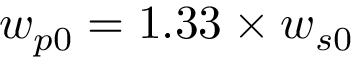<formula> <loc_0><loc_0><loc_500><loc_500>w _ { p 0 } = 1 . 3 3 \times w _ { s 0 }</formula> 